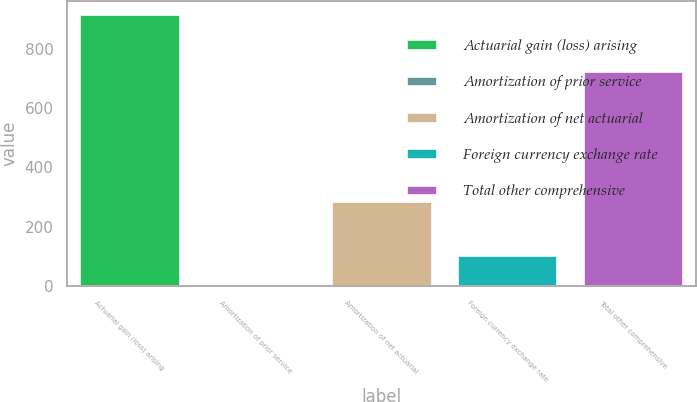<chart> <loc_0><loc_0><loc_500><loc_500><bar_chart><fcel>Actuarial gain (loss) arising<fcel>Amortization of prior service<fcel>Amortization of net actuarial<fcel>Foreign currency exchange rate<fcel>Total other comprehensive<nl><fcel>915.1<fcel>5.7<fcel>288.2<fcel>105.3<fcel>723.3<nl></chart> 